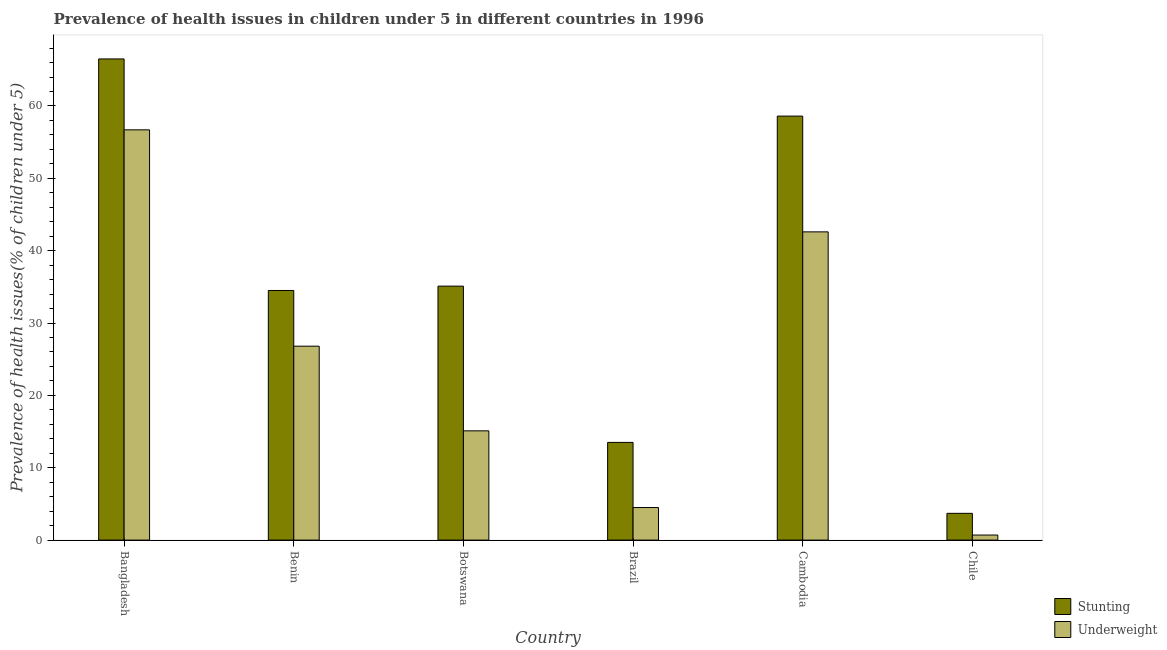How many different coloured bars are there?
Provide a succinct answer. 2. How many groups of bars are there?
Offer a very short reply. 6. Are the number of bars per tick equal to the number of legend labels?
Offer a terse response. Yes. Are the number of bars on each tick of the X-axis equal?
Offer a terse response. Yes. How many bars are there on the 6th tick from the right?
Give a very brief answer. 2. What is the label of the 1st group of bars from the left?
Offer a terse response. Bangladesh. What is the percentage of stunted children in Chile?
Ensure brevity in your answer.  3.7. Across all countries, what is the maximum percentage of stunted children?
Offer a very short reply. 66.5. Across all countries, what is the minimum percentage of underweight children?
Offer a terse response. 0.7. In which country was the percentage of stunted children minimum?
Your response must be concise. Chile. What is the total percentage of stunted children in the graph?
Provide a short and direct response. 211.9. What is the difference between the percentage of stunted children in Cambodia and that in Chile?
Keep it short and to the point. 54.9. What is the difference between the percentage of underweight children in Bangladesh and the percentage of stunted children in Chile?
Ensure brevity in your answer.  53. What is the average percentage of stunted children per country?
Make the answer very short. 35.32. What is the difference between the percentage of underweight children and percentage of stunted children in Botswana?
Your answer should be very brief. -20. In how many countries, is the percentage of underweight children greater than 56 %?
Make the answer very short. 1. What is the ratio of the percentage of underweight children in Botswana to that in Chile?
Your answer should be very brief. 21.57. What is the difference between the highest and the second highest percentage of stunted children?
Your answer should be compact. 7.9. What is the difference between the highest and the lowest percentage of underweight children?
Provide a short and direct response. 56. In how many countries, is the percentage of underweight children greater than the average percentage of underweight children taken over all countries?
Ensure brevity in your answer.  3. Is the sum of the percentage of stunted children in Bangladesh and Chile greater than the maximum percentage of underweight children across all countries?
Ensure brevity in your answer.  Yes. What does the 2nd bar from the left in Brazil represents?
Make the answer very short. Underweight. What does the 1st bar from the right in Cambodia represents?
Your answer should be compact. Underweight. How many bars are there?
Keep it short and to the point. 12. How many countries are there in the graph?
Give a very brief answer. 6. Does the graph contain any zero values?
Provide a short and direct response. No. Does the graph contain grids?
Offer a very short reply. No. Where does the legend appear in the graph?
Give a very brief answer. Bottom right. How many legend labels are there?
Provide a short and direct response. 2. How are the legend labels stacked?
Ensure brevity in your answer.  Vertical. What is the title of the graph?
Make the answer very short. Prevalence of health issues in children under 5 in different countries in 1996. Does "Nitrous oxide emissions" appear as one of the legend labels in the graph?
Give a very brief answer. No. What is the label or title of the Y-axis?
Give a very brief answer. Prevalence of health issues(% of children under 5). What is the Prevalence of health issues(% of children under 5) in Stunting in Bangladesh?
Keep it short and to the point. 66.5. What is the Prevalence of health issues(% of children under 5) of Underweight in Bangladesh?
Your answer should be very brief. 56.7. What is the Prevalence of health issues(% of children under 5) of Stunting in Benin?
Your answer should be very brief. 34.5. What is the Prevalence of health issues(% of children under 5) of Underweight in Benin?
Your response must be concise. 26.8. What is the Prevalence of health issues(% of children under 5) of Stunting in Botswana?
Provide a succinct answer. 35.1. What is the Prevalence of health issues(% of children under 5) in Underweight in Botswana?
Provide a short and direct response. 15.1. What is the Prevalence of health issues(% of children under 5) of Stunting in Brazil?
Make the answer very short. 13.5. What is the Prevalence of health issues(% of children under 5) of Stunting in Cambodia?
Offer a terse response. 58.6. What is the Prevalence of health issues(% of children under 5) of Underweight in Cambodia?
Your response must be concise. 42.6. What is the Prevalence of health issues(% of children under 5) in Stunting in Chile?
Give a very brief answer. 3.7. What is the Prevalence of health issues(% of children under 5) of Underweight in Chile?
Give a very brief answer. 0.7. Across all countries, what is the maximum Prevalence of health issues(% of children under 5) in Stunting?
Provide a short and direct response. 66.5. Across all countries, what is the maximum Prevalence of health issues(% of children under 5) of Underweight?
Ensure brevity in your answer.  56.7. Across all countries, what is the minimum Prevalence of health issues(% of children under 5) in Stunting?
Provide a short and direct response. 3.7. Across all countries, what is the minimum Prevalence of health issues(% of children under 5) of Underweight?
Keep it short and to the point. 0.7. What is the total Prevalence of health issues(% of children under 5) of Stunting in the graph?
Offer a very short reply. 211.9. What is the total Prevalence of health issues(% of children under 5) of Underweight in the graph?
Keep it short and to the point. 146.4. What is the difference between the Prevalence of health issues(% of children under 5) in Underweight in Bangladesh and that in Benin?
Your answer should be compact. 29.9. What is the difference between the Prevalence of health issues(% of children under 5) of Stunting in Bangladesh and that in Botswana?
Provide a succinct answer. 31.4. What is the difference between the Prevalence of health issues(% of children under 5) in Underweight in Bangladesh and that in Botswana?
Provide a succinct answer. 41.6. What is the difference between the Prevalence of health issues(% of children under 5) of Stunting in Bangladesh and that in Brazil?
Keep it short and to the point. 53. What is the difference between the Prevalence of health issues(% of children under 5) in Underweight in Bangladesh and that in Brazil?
Your answer should be very brief. 52.2. What is the difference between the Prevalence of health issues(% of children under 5) in Stunting in Bangladesh and that in Cambodia?
Ensure brevity in your answer.  7.9. What is the difference between the Prevalence of health issues(% of children under 5) of Underweight in Bangladesh and that in Cambodia?
Provide a short and direct response. 14.1. What is the difference between the Prevalence of health issues(% of children under 5) in Stunting in Bangladesh and that in Chile?
Make the answer very short. 62.8. What is the difference between the Prevalence of health issues(% of children under 5) in Underweight in Bangladesh and that in Chile?
Ensure brevity in your answer.  56. What is the difference between the Prevalence of health issues(% of children under 5) of Underweight in Benin and that in Botswana?
Your response must be concise. 11.7. What is the difference between the Prevalence of health issues(% of children under 5) in Underweight in Benin and that in Brazil?
Offer a terse response. 22.3. What is the difference between the Prevalence of health issues(% of children under 5) in Stunting in Benin and that in Cambodia?
Provide a short and direct response. -24.1. What is the difference between the Prevalence of health issues(% of children under 5) of Underweight in Benin and that in Cambodia?
Provide a succinct answer. -15.8. What is the difference between the Prevalence of health issues(% of children under 5) of Stunting in Benin and that in Chile?
Your answer should be compact. 30.8. What is the difference between the Prevalence of health issues(% of children under 5) in Underweight in Benin and that in Chile?
Your answer should be very brief. 26.1. What is the difference between the Prevalence of health issues(% of children under 5) in Stunting in Botswana and that in Brazil?
Offer a terse response. 21.6. What is the difference between the Prevalence of health issues(% of children under 5) of Underweight in Botswana and that in Brazil?
Offer a terse response. 10.6. What is the difference between the Prevalence of health issues(% of children under 5) of Stunting in Botswana and that in Cambodia?
Your answer should be very brief. -23.5. What is the difference between the Prevalence of health issues(% of children under 5) in Underweight in Botswana and that in Cambodia?
Ensure brevity in your answer.  -27.5. What is the difference between the Prevalence of health issues(% of children under 5) in Stunting in Botswana and that in Chile?
Keep it short and to the point. 31.4. What is the difference between the Prevalence of health issues(% of children under 5) of Stunting in Brazil and that in Cambodia?
Make the answer very short. -45.1. What is the difference between the Prevalence of health issues(% of children under 5) of Underweight in Brazil and that in Cambodia?
Your response must be concise. -38.1. What is the difference between the Prevalence of health issues(% of children under 5) of Stunting in Brazil and that in Chile?
Your response must be concise. 9.8. What is the difference between the Prevalence of health issues(% of children under 5) in Underweight in Brazil and that in Chile?
Make the answer very short. 3.8. What is the difference between the Prevalence of health issues(% of children under 5) of Stunting in Cambodia and that in Chile?
Your response must be concise. 54.9. What is the difference between the Prevalence of health issues(% of children under 5) in Underweight in Cambodia and that in Chile?
Make the answer very short. 41.9. What is the difference between the Prevalence of health issues(% of children under 5) in Stunting in Bangladesh and the Prevalence of health issues(% of children under 5) in Underweight in Benin?
Offer a very short reply. 39.7. What is the difference between the Prevalence of health issues(% of children under 5) of Stunting in Bangladesh and the Prevalence of health issues(% of children under 5) of Underweight in Botswana?
Ensure brevity in your answer.  51.4. What is the difference between the Prevalence of health issues(% of children under 5) of Stunting in Bangladesh and the Prevalence of health issues(% of children under 5) of Underweight in Cambodia?
Ensure brevity in your answer.  23.9. What is the difference between the Prevalence of health issues(% of children under 5) of Stunting in Bangladesh and the Prevalence of health issues(% of children under 5) of Underweight in Chile?
Your response must be concise. 65.8. What is the difference between the Prevalence of health issues(% of children under 5) of Stunting in Benin and the Prevalence of health issues(% of children under 5) of Underweight in Botswana?
Offer a terse response. 19.4. What is the difference between the Prevalence of health issues(% of children under 5) of Stunting in Benin and the Prevalence of health issues(% of children under 5) of Underweight in Brazil?
Offer a terse response. 30. What is the difference between the Prevalence of health issues(% of children under 5) in Stunting in Benin and the Prevalence of health issues(% of children under 5) in Underweight in Cambodia?
Offer a terse response. -8.1. What is the difference between the Prevalence of health issues(% of children under 5) of Stunting in Benin and the Prevalence of health issues(% of children under 5) of Underweight in Chile?
Provide a short and direct response. 33.8. What is the difference between the Prevalence of health issues(% of children under 5) in Stunting in Botswana and the Prevalence of health issues(% of children under 5) in Underweight in Brazil?
Make the answer very short. 30.6. What is the difference between the Prevalence of health issues(% of children under 5) of Stunting in Botswana and the Prevalence of health issues(% of children under 5) of Underweight in Cambodia?
Make the answer very short. -7.5. What is the difference between the Prevalence of health issues(% of children under 5) of Stunting in Botswana and the Prevalence of health issues(% of children under 5) of Underweight in Chile?
Give a very brief answer. 34.4. What is the difference between the Prevalence of health issues(% of children under 5) of Stunting in Brazil and the Prevalence of health issues(% of children under 5) of Underweight in Cambodia?
Give a very brief answer. -29.1. What is the difference between the Prevalence of health issues(% of children under 5) in Stunting in Cambodia and the Prevalence of health issues(% of children under 5) in Underweight in Chile?
Provide a succinct answer. 57.9. What is the average Prevalence of health issues(% of children under 5) in Stunting per country?
Your answer should be very brief. 35.32. What is the average Prevalence of health issues(% of children under 5) of Underweight per country?
Provide a short and direct response. 24.4. What is the difference between the Prevalence of health issues(% of children under 5) in Stunting and Prevalence of health issues(% of children under 5) in Underweight in Botswana?
Your answer should be compact. 20. What is the difference between the Prevalence of health issues(% of children under 5) of Stunting and Prevalence of health issues(% of children under 5) of Underweight in Cambodia?
Ensure brevity in your answer.  16. What is the ratio of the Prevalence of health issues(% of children under 5) of Stunting in Bangladesh to that in Benin?
Offer a very short reply. 1.93. What is the ratio of the Prevalence of health issues(% of children under 5) in Underweight in Bangladesh to that in Benin?
Provide a short and direct response. 2.12. What is the ratio of the Prevalence of health issues(% of children under 5) in Stunting in Bangladesh to that in Botswana?
Keep it short and to the point. 1.89. What is the ratio of the Prevalence of health issues(% of children under 5) of Underweight in Bangladesh to that in Botswana?
Offer a very short reply. 3.75. What is the ratio of the Prevalence of health issues(% of children under 5) in Stunting in Bangladesh to that in Brazil?
Provide a short and direct response. 4.93. What is the ratio of the Prevalence of health issues(% of children under 5) of Stunting in Bangladesh to that in Cambodia?
Provide a short and direct response. 1.13. What is the ratio of the Prevalence of health issues(% of children under 5) in Underweight in Bangladesh to that in Cambodia?
Give a very brief answer. 1.33. What is the ratio of the Prevalence of health issues(% of children under 5) of Stunting in Bangladesh to that in Chile?
Offer a very short reply. 17.97. What is the ratio of the Prevalence of health issues(% of children under 5) of Underweight in Bangladesh to that in Chile?
Provide a short and direct response. 81. What is the ratio of the Prevalence of health issues(% of children under 5) in Stunting in Benin to that in Botswana?
Offer a very short reply. 0.98. What is the ratio of the Prevalence of health issues(% of children under 5) in Underweight in Benin to that in Botswana?
Your answer should be very brief. 1.77. What is the ratio of the Prevalence of health issues(% of children under 5) in Stunting in Benin to that in Brazil?
Make the answer very short. 2.56. What is the ratio of the Prevalence of health issues(% of children under 5) in Underweight in Benin to that in Brazil?
Keep it short and to the point. 5.96. What is the ratio of the Prevalence of health issues(% of children under 5) in Stunting in Benin to that in Cambodia?
Keep it short and to the point. 0.59. What is the ratio of the Prevalence of health issues(% of children under 5) of Underweight in Benin to that in Cambodia?
Your answer should be very brief. 0.63. What is the ratio of the Prevalence of health issues(% of children under 5) of Stunting in Benin to that in Chile?
Offer a terse response. 9.32. What is the ratio of the Prevalence of health issues(% of children under 5) in Underweight in Benin to that in Chile?
Your response must be concise. 38.29. What is the ratio of the Prevalence of health issues(% of children under 5) in Stunting in Botswana to that in Brazil?
Your answer should be compact. 2.6. What is the ratio of the Prevalence of health issues(% of children under 5) in Underweight in Botswana to that in Brazil?
Your response must be concise. 3.36. What is the ratio of the Prevalence of health issues(% of children under 5) of Stunting in Botswana to that in Cambodia?
Keep it short and to the point. 0.6. What is the ratio of the Prevalence of health issues(% of children under 5) of Underweight in Botswana to that in Cambodia?
Ensure brevity in your answer.  0.35. What is the ratio of the Prevalence of health issues(% of children under 5) of Stunting in Botswana to that in Chile?
Keep it short and to the point. 9.49. What is the ratio of the Prevalence of health issues(% of children under 5) of Underweight in Botswana to that in Chile?
Make the answer very short. 21.57. What is the ratio of the Prevalence of health issues(% of children under 5) in Stunting in Brazil to that in Cambodia?
Your answer should be compact. 0.23. What is the ratio of the Prevalence of health issues(% of children under 5) in Underweight in Brazil to that in Cambodia?
Give a very brief answer. 0.11. What is the ratio of the Prevalence of health issues(% of children under 5) in Stunting in Brazil to that in Chile?
Ensure brevity in your answer.  3.65. What is the ratio of the Prevalence of health issues(% of children under 5) of Underweight in Brazil to that in Chile?
Keep it short and to the point. 6.43. What is the ratio of the Prevalence of health issues(% of children under 5) of Stunting in Cambodia to that in Chile?
Keep it short and to the point. 15.84. What is the ratio of the Prevalence of health issues(% of children under 5) of Underweight in Cambodia to that in Chile?
Provide a succinct answer. 60.86. What is the difference between the highest and the second highest Prevalence of health issues(% of children under 5) of Underweight?
Offer a very short reply. 14.1. What is the difference between the highest and the lowest Prevalence of health issues(% of children under 5) in Stunting?
Keep it short and to the point. 62.8. 